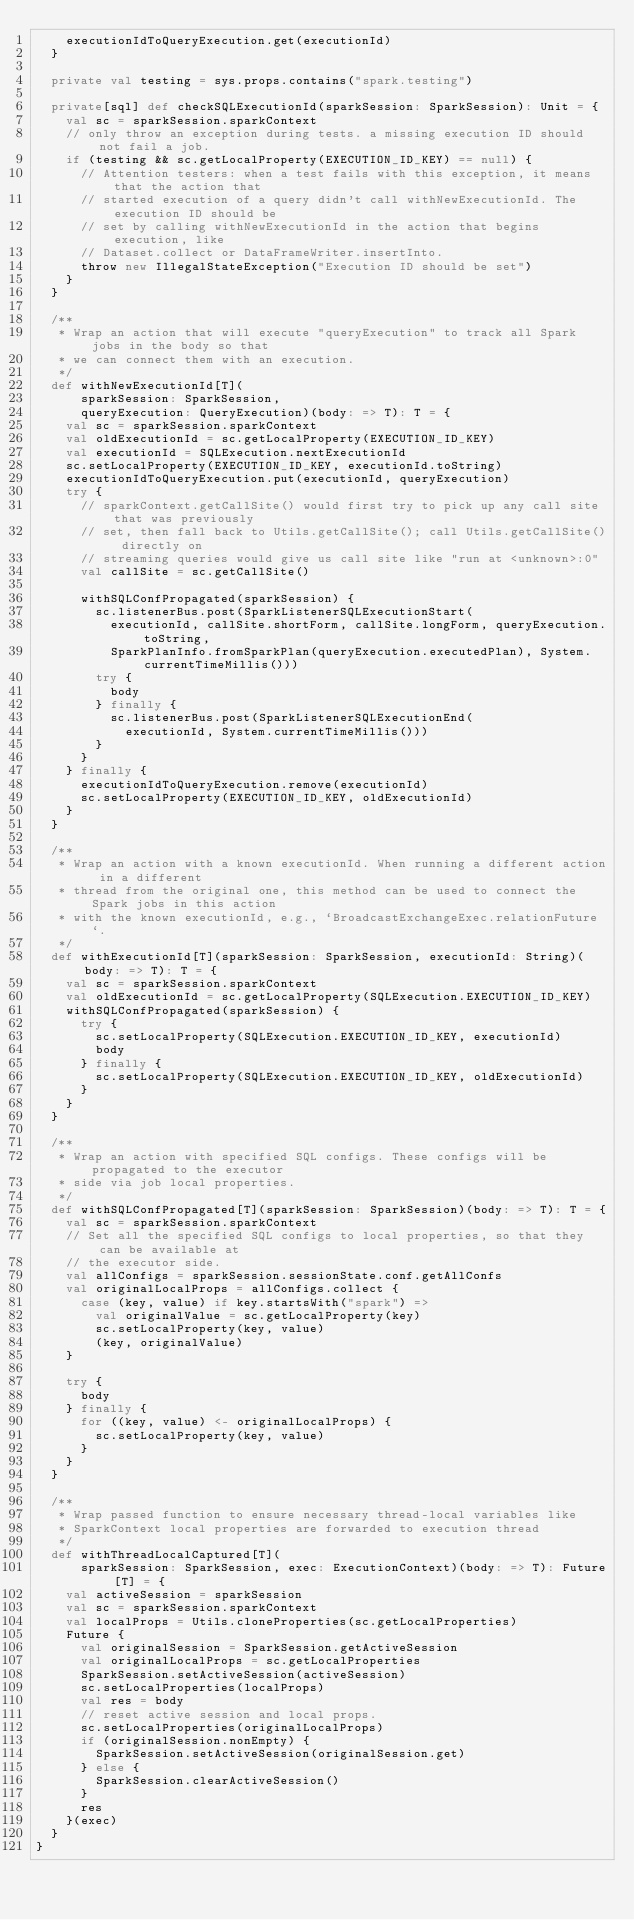Convert code to text. <code><loc_0><loc_0><loc_500><loc_500><_Scala_>    executionIdToQueryExecution.get(executionId)
  }

  private val testing = sys.props.contains("spark.testing")

  private[sql] def checkSQLExecutionId(sparkSession: SparkSession): Unit = {
    val sc = sparkSession.sparkContext
    // only throw an exception during tests. a missing execution ID should not fail a job.
    if (testing && sc.getLocalProperty(EXECUTION_ID_KEY) == null) {
      // Attention testers: when a test fails with this exception, it means that the action that
      // started execution of a query didn't call withNewExecutionId. The execution ID should be
      // set by calling withNewExecutionId in the action that begins execution, like
      // Dataset.collect or DataFrameWriter.insertInto.
      throw new IllegalStateException("Execution ID should be set")
    }
  }

  /**
   * Wrap an action that will execute "queryExecution" to track all Spark jobs in the body so that
   * we can connect them with an execution.
   */
  def withNewExecutionId[T](
      sparkSession: SparkSession,
      queryExecution: QueryExecution)(body: => T): T = {
    val sc = sparkSession.sparkContext
    val oldExecutionId = sc.getLocalProperty(EXECUTION_ID_KEY)
    val executionId = SQLExecution.nextExecutionId
    sc.setLocalProperty(EXECUTION_ID_KEY, executionId.toString)
    executionIdToQueryExecution.put(executionId, queryExecution)
    try {
      // sparkContext.getCallSite() would first try to pick up any call site that was previously
      // set, then fall back to Utils.getCallSite(); call Utils.getCallSite() directly on
      // streaming queries would give us call site like "run at <unknown>:0"
      val callSite = sc.getCallSite()

      withSQLConfPropagated(sparkSession) {
        sc.listenerBus.post(SparkListenerSQLExecutionStart(
          executionId, callSite.shortForm, callSite.longForm, queryExecution.toString,
          SparkPlanInfo.fromSparkPlan(queryExecution.executedPlan), System.currentTimeMillis()))
        try {
          body
        } finally {
          sc.listenerBus.post(SparkListenerSQLExecutionEnd(
            executionId, System.currentTimeMillis()))
        }
      }
    } finally {
      executionIdToQueryExecution.remove(executionId)
      sc.setLocalProperty(EXECUTION_ID_KEY, oldExecutionId)
    }
  }

  /**
   * Wrap an action with a known executionId. When running a different action in a different
   * thread from the original one, this method can be used to connect the Spark jobs in this action
   * with the known executionId, e.g., `BroadcastExchangeExec.relationFuture`.
   */
  def withExecutionId[T](sparkSession: SparkSession, executionId: String)(body: => T): T = {
    val sc = sparkSession.sparkContext
    val oldExecutionId = sc.getLocalProperty(SQLExecution.EXECUTION_ID_KEY)
    withSQLConfPropagated(sparkSession) {
      try {
        sc.setLocalProperty(SQLExecution.EXECUTION_ID_KEY, executionId)
        body
      } finally {
        sc.setLocalProperty(SQLExecution.EXECUTION_ID_KEY, oldExecutionId)
      }
    }
  }

  /**
   * Wrap an action with specified SQL configs. These configs will be propagated to the executor
   * side via job local properties.
   */
  def withSQLConfPropagated[T](sparkSession: SparkSession)(body: => T): T = {
    val sc = sparkSession.sparkContext
    // Set all the specified SQL configs to local properties, so that they can be available at
    // the executor side.
    val allConfigs = sparkSession.sessionState.conf.getAllConfs
    val originalLocalProps = allConfigs.collect {
      case (key, value) if key.startsWith("spark") =>
        val originalValue = sc.getLocalProperty(key)
        sc.setLocalProperty(key, value)
        (key, originalValue)
    }

    try {
      body
    } finally {
      for ((key, value) <- originalLocalProps) {
        sc.setLocalProperty(key, value)
      }
    }
  }

  /**
   * Wrap passed function to ensure necessary thread-local variables like
   * SparkContext local properties are forwarded to execution thread
   */
  def withThreadLocalCaptured[T](
      sparkSession: SparkSession, exec: ExecutionContext)(body: => T): Future[T] = {
    val activeSession = sparkSession
    val sc = sparkSession.sparkContext
    val localProps = Utils.cloneProperties(sc.getLocalProperties)
    Future {
      val originalSession = SparkSession.getActiveSession
      val originalLocalProps = sc.getLocalProperties
      SparkSession.setActiveSession(activeSession)
      sc.setLocalProperties(localProps)
      val res = body
      // reset active session and local props.
      sc.setLocalProperties(originalLocalProps)
      if (originalSession.nonEmpty) {
        SparkSession.setActiveSession(originalSession.get)
      } else {
        SparkSession.clearActiveSession()
      }
      res
    }(exec)
  }
}
</code> 